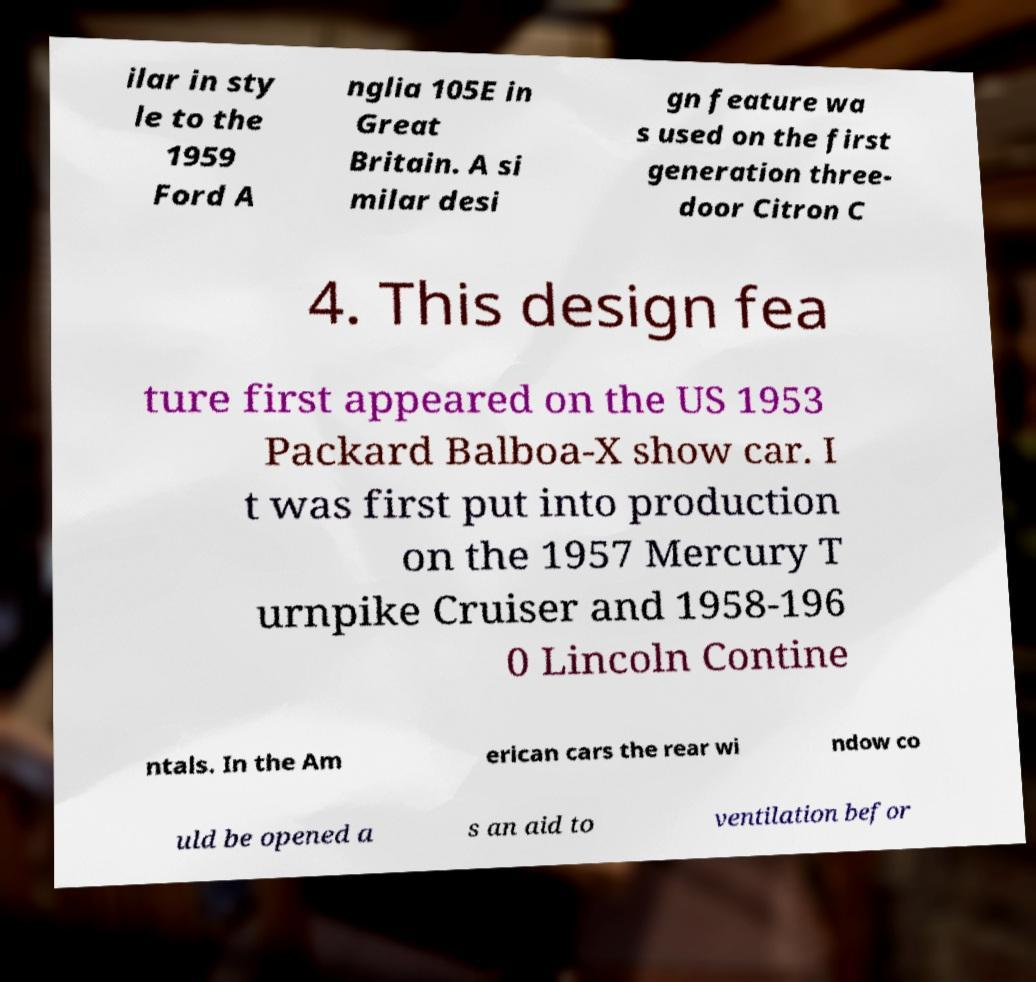There's text embedded in this image that I need extracted. Can you transcribe it verbatim? ilar in sty le to the 1959 Ford A nglia 105E in Great Britain. A si milar desi gn feature wa s used on the first generation three- door Citron C 4. This design fea ture first appeared on the US 1953 Packard Balboa-X show car. I t was first put into production on the 1957 Mercury T urnpike Cruiser and 1958-196 0 Lincoln Contine ntals. In the Am erican cars the rear wi ndow co uld be opened a s an aid to ventilation befor 